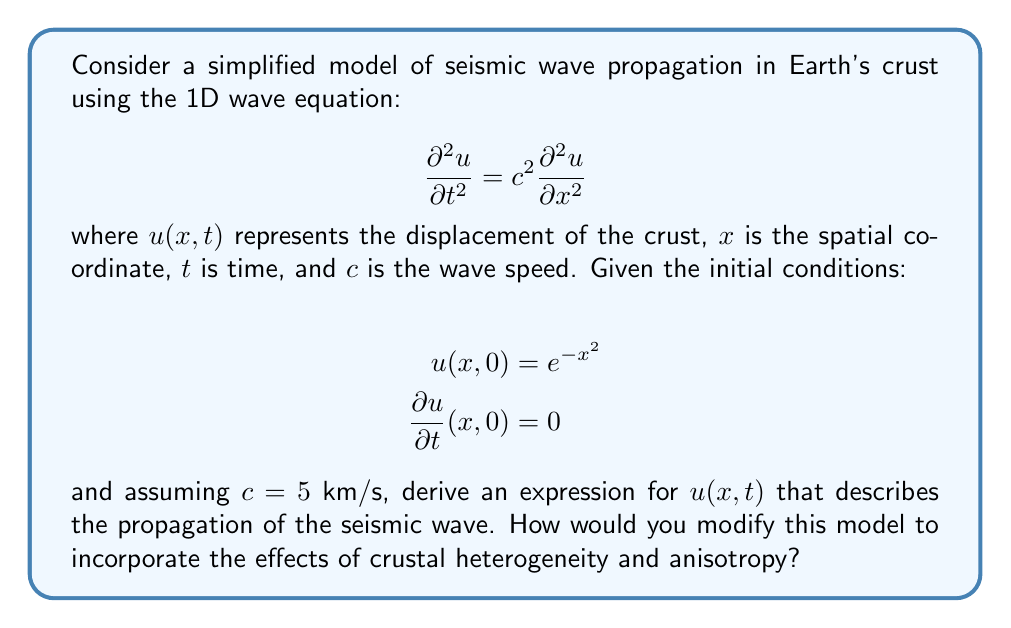Can you answer this question? To solve this problem, we'll follow these steps:

1) The general solution to the 1D wave equation is given by D'Alembert's formula:

   $$u(x,t) = \frac{1}{2}[f(x+ct) + f(x-ct)] + \frac{1}{2c}\int_{x-ct}^{x+ct} g(s) ds$$

   where $f$ and $g$ are determined by the initial conditions.

2) From the initial conditions, we can deduce:
   
   $$f(x) = e^{-x^2}$$ (from $u(x,0) = e^{-x^2}$)
   $$g(x) = 0$$ (from $\frac{\partial u}{\partial t}(x,0) = 0$)

3) Substituting these into D'Alembert's formula:

   $$u(x,t) = \frac{1}{2}[e^{-(x+ct)^2} + e^{-(x-ct)^2}]$$

4) Substituting $c = 5$ km/s:

   $$u(x,t) = \frac{1}{2}[e^{-(x+5t)^2} + e^{-(x-5t)^2}]$$

This expression describes the propagation of the seismic wave in this simplified model.

To modify the model for crustal heterogeneity and anisotropy:

1) Heterogeneity: Replace the constant $c$ with a function $c(x)$ to represent varying wave speeds in different layers of the crust.

2) Anisotropy: Introduce directional dependence by using a tensor $c_{ij}$ instead of a scalar $c$, leading to a more complex wave equation:

   $$\frac{\partial^2 u_i}{\partial t^2} = c_{ijkl} \frac{\partial^2 u_k}{\partial x_j \partial x_l}$$

These modifications would significantly increase the complexity of the model but provide a more accurate representation of seismic wave propagation in Earth's crust.
Answer: $u(x,t) = \frac{1}{2}[e^{-(x+5t)^2} + e^{-(x-5t)^2}]$ 